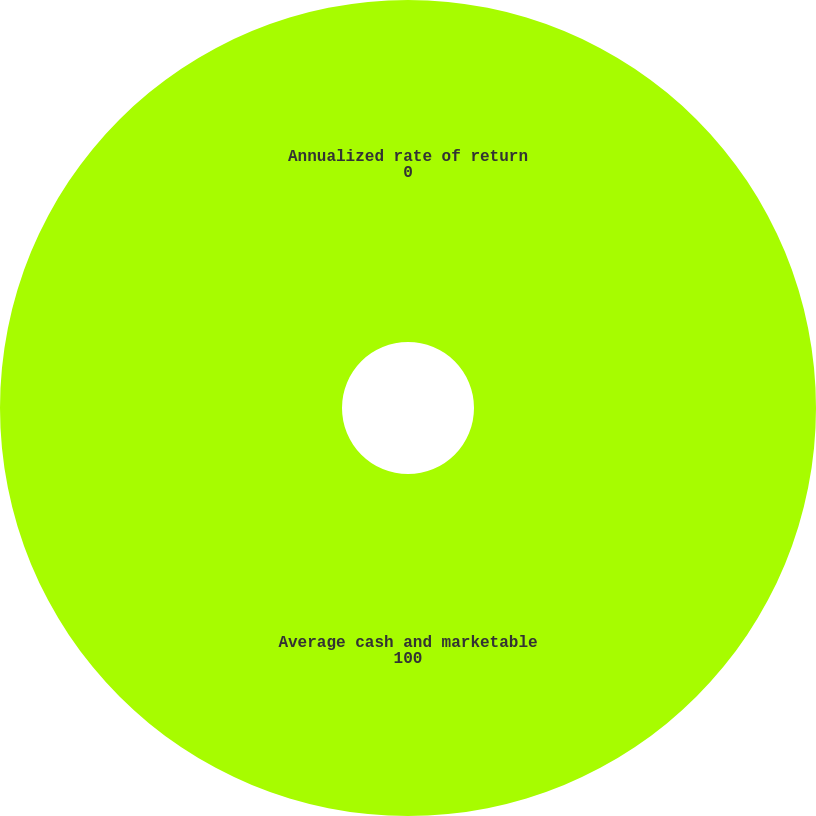<chart> <loc_0><loc_0><loc_500><loc_500><pie_chart><fcel>Average cash and marketable<fcel>Annualized rate of return<nl><fcel>100.0%<fcel>0.0%<nl></chart> 